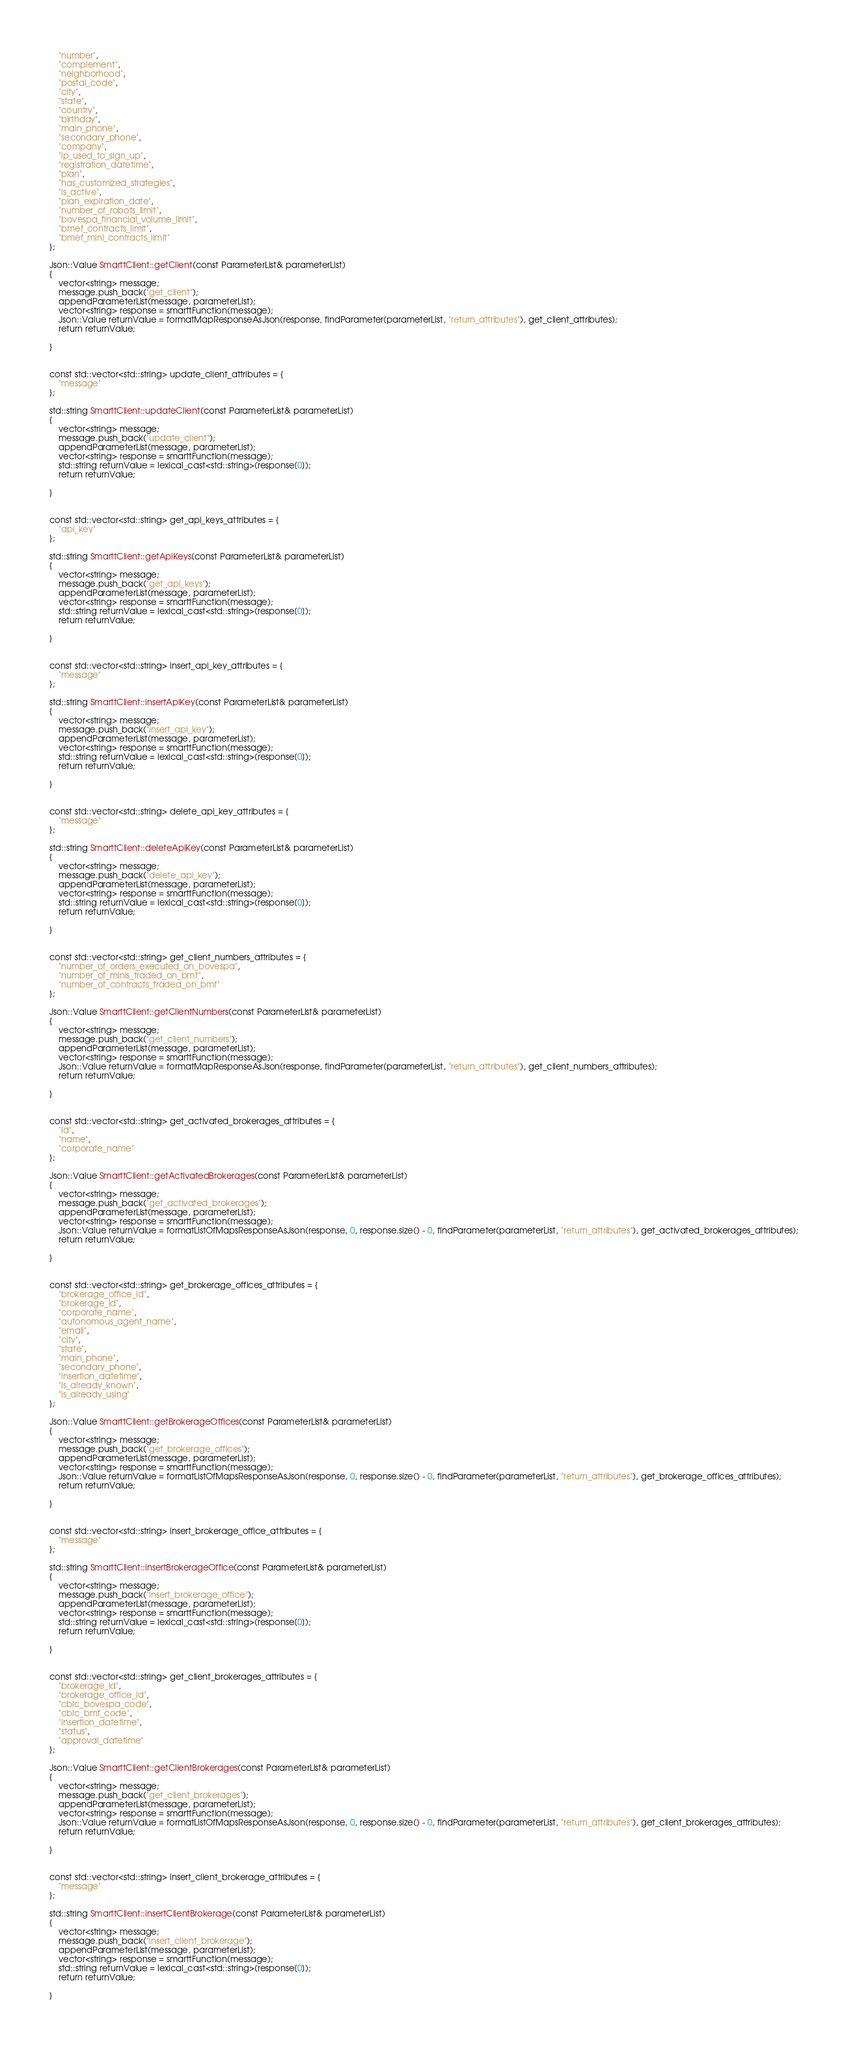Convert code to text. <code><loc_0><loc_0><loc_500><loc_500><_C++_>    "number",
    "complement",
    "neighborhood",
    "postal_code",
    "city",
    "state",
    "country",
    "birthday",
    "main_phone",
    "secondary_phone",
    "company",
    "ip_used_to_sign_up",
    "registration_datetime",
    "plan",
    "has_customized_strategies",
    "is_active",
    "plan_expiration_date",
    "number_of_robots_limit",
    "bovespa_financial_volume_limit",
    "bmef_contracts_limit",
    "bmef_mini_contracts_limit"
};

Json::Value SmarttClient::getClient(const ParameterList& parameterList)
{
    vector<string> message;
    message.push_back("get_client");
    appendParameterList(message, parameterList);
    vector<string> response = smarttFunction(message);
    Json::Value returnValue = formatMapResponseAsJson(response, findParameter(parameterList, "return_attributes"), get_client_attributes);
    return returnValue;

}


const std::vector<std::string> update_client_attributes = {
    "message"
};

std::string SmarttClient::updateClient(const ParameterList& parameterList)
{
    vector<string> message;
    message.push_back("update_client");
    appendParameterList(message, parameterList);
    vector<string> response = smarttFunction(message);
    std::string returnValue = lexical_cast<std::string>(response[0]);
    return returnValue;

}


const std::vector<std::string> get_api_keys_attributes = {
    "api_key"
};

std::string SmarttClient::getApiKeys(const ParameterList& parameterList)
{
    vector<string> message;
    message.push_back("get_api_keys");
    appendParameterList(message, parameterList);
    vector<string> response = smarttFunction(message);
    std::string returnValue = lexical_cast<std::string>(response[0]);
    return returnValue;

}


const std::vector<std::string> insert_api_key_attributes = {
    "message"
};

std::string SmarttClient::insertApiKey(const ParameterList& parameterList)
{
    vector<string> message;
    message.push_back("insert_api_key");
    appendParameterList(message, parameterList);
    vector<string> response = smarttFunction(message);
    std::string returnValue = lexical_cast<std::string>(response[0]);
    return returnValue;

}


const std::vector<std::string> delete_api_key_attributes = {
    "message"
};

std::string SmarttClient::deleteApiKey(const ParameterList& parameterList)
{
    vector<string> message;
    message.push_back("delete_api_key");
    appendParameterList(message, parameterList);
    vector<string> response = smarttFunction(message);
    std::string returnValue = lexical_cast<std::string>(response[0]);
    return returnValue;

}


const std::vector<std::string> get_client_numbers_attributes = {
    "number_of_orders_executed_on_bovespa",
    "number_of_minis_traded_on_bmf",
    "number_of_contracts_traded_on_bmf"
};

Json::Value SmarttClient::getClientNumbers(const ParameterList& parameterList)
{
    vector<string> message;
    message.push_back("get_client_numbers");
    appendParameterList(message, parameterList);
    vector<string> response = smarttFunction(message);
    Json::Value returnValue = formatMapResponseAsJson(response, findParameter(parameterList, "return_attributes"), get_client_numbers_attributes);
    return returnValue;

}


const std::vector<std::string> get_activated_brokerages_attributes = {
    "id",
    "name",
    "corporate_name"
};

Json::Value SmarttClient::getActivatedBrokerages(const ParameterList& parameterList)
{
    vector<string> message;
    message.push_back("get_activated_brokerages");
    appendParameterList(message, parameterList);
    vector<string> response = smarttFunction(message);
    Json::Value returnValue = formatListOfMapsResponseAsJson(response, 0, response.size() - 0, findParameter(parameterList, "return_attributes"), get_activated_brokerages_attributes);
    return returnValue;

}


const std::vector<std::string> get_brokerage_offices_attributes = {
    "brokerage_office_id",
    "brokerage_id",
    "corporate_name",
    "autonomous_agent_name",
    "email",
    "city",
    "state",
    "main_phone",
    "secondary_phone",
    "insertion_datetime",
    "is_already_known",
    "is_already_using"
};

Json::Value SmarttClient::getBrokerageOffices(const ParameterList& parameterList)
{
    vector<string> message;
    message.push_back("get_brokerage_offices");
    appendParameterList(message, parameterList);
    vector<string> response = smarttFunction(message);
    Json::Value returnValue = formatListOfMapsResponseAsJson(response, 0, response.size() - 0, findParameter(parameterList, "return_attributes"), get_brokerage_offices_attributes);
    return returnValue;

}


const std::vector<std::string> insert_brokerage_office_attributes = {
    "message"
};

std::string SmarttClient::insertBrokerageOffice(const ParameterList& parameterList)
{
    vector<string> message;
    message.push_back("insert_brokerage_office");
    appendParameterList(message, parameterList);
    vector<string> response = smarttFunction(message);
    std::string returnValue = lexical_cast<std::string>(response[0]);
    return returnValue;

}


const std::vector<std::string> get_client_brokerages_attributes = {
    "brokerage_id",
    "brokerage_office_id",
    "cblc_bovespa_code",
    "cblc_bmf_code",
    "insertion_datetime",
    "status",
    "approval_datetime"
};

Json::Value SmarttClient::getClientBrokerages(const ParameterList& parameterList)
{
    vector<string> message;
    message.push_back("get_client_brokerages");
    appendParameterList(message, parameterList);
    vector<string> response = smarttFunction(message);
    Json::Value returnValue = formatListOfMapsResponseAsJson(response, 0, response.size() - 0, findParameter(parameterList, "return_attributes"), get_client_brokerages_attributes);
    return returnValue;

}


const std::vector<std::string> insert_client_brokerage_attributes = {
    "message"
};

std::string SmarttClient::insertClientBrokerage(const ParameterList& parameterList)
{
    vector<string> message;
    message.push_back("insert_client_brokerage");
    appendParameterList(message, parameterList);
    vector<string> response = smarttFunction(message);
    std::string returnValue = lexical_cast<std::string>(response[0]);
    return returnValue;

}

</code> 